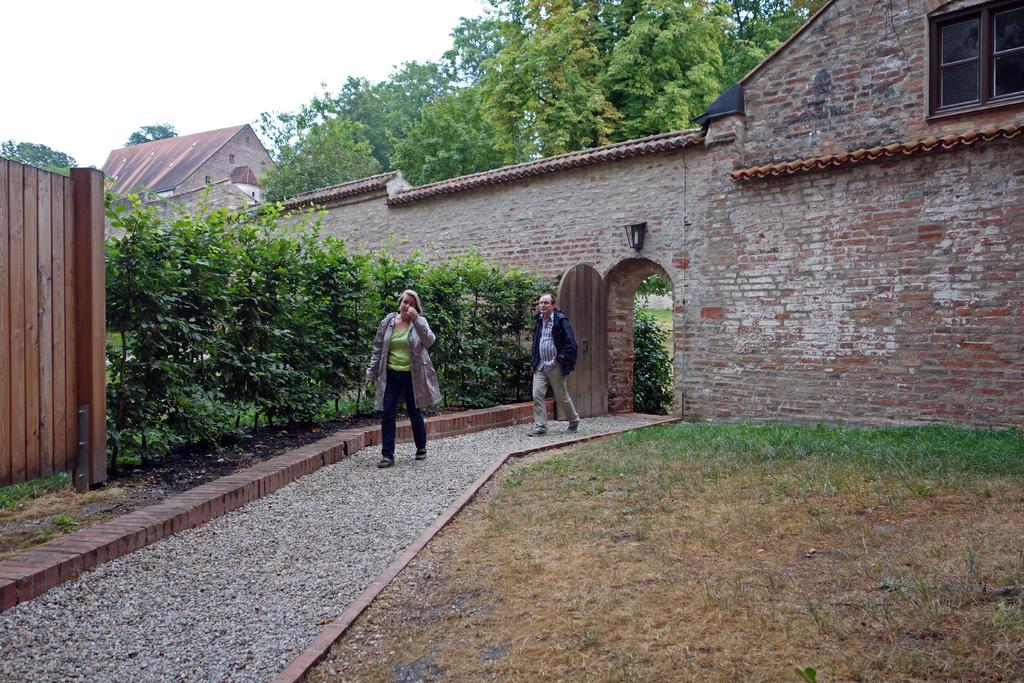How many people are in the image? There are two people in the image, a man and a woman. What are the man and woman doing in the image? The man and woman are walking. What can be seen in the background of the image? There are buildings, trees, and grass in the background of the image. What surface are the man and woman walking on? They are walking on stones. What word or verse is written on the suit the man is wearing in the image? There is no suit or any written word or verse visible on the man's clothing in the image. 